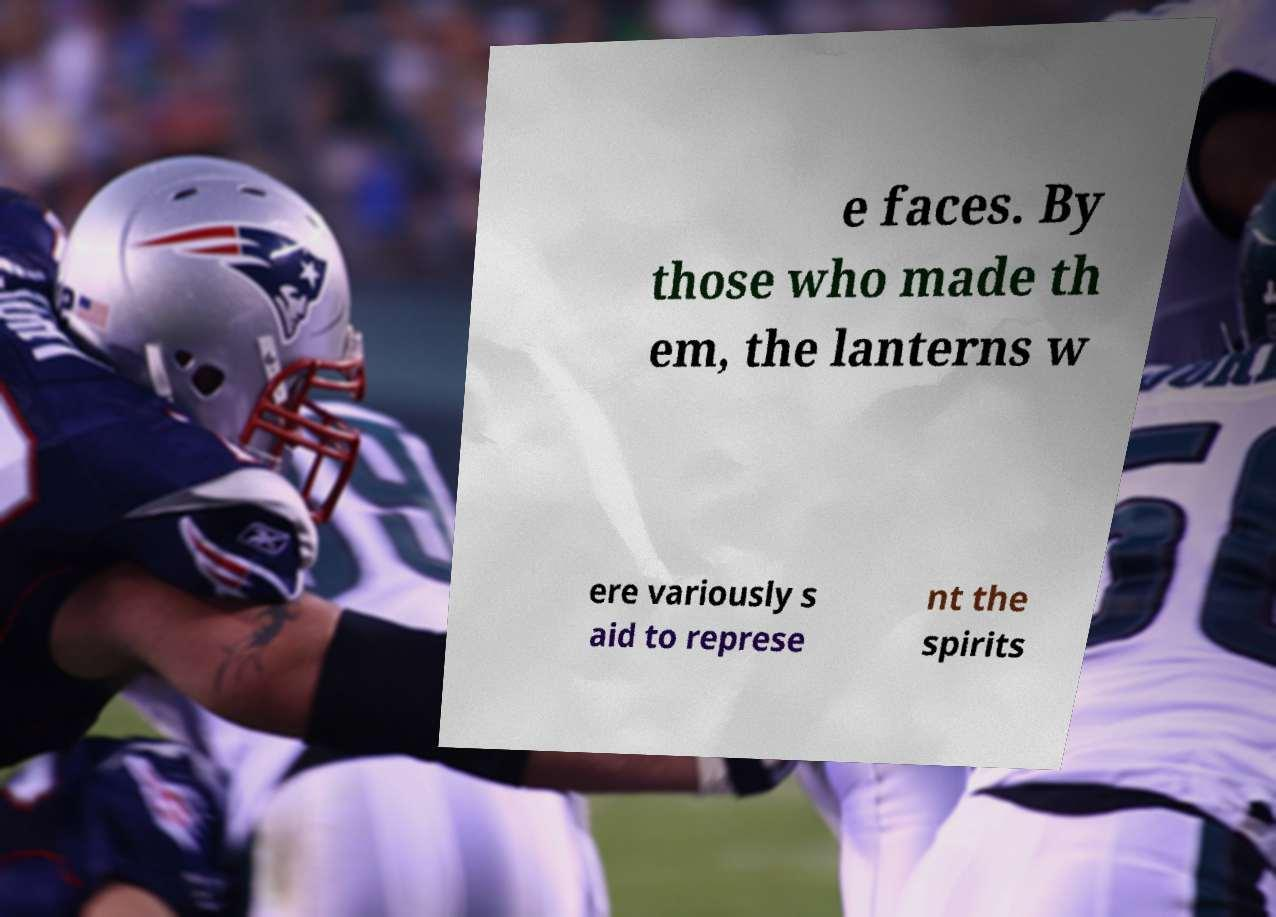I need the written content from this picture converted into text. Can you do that? e faces. By those who made th em, the lanterns w ere variously s aid to represe nt the spirits 